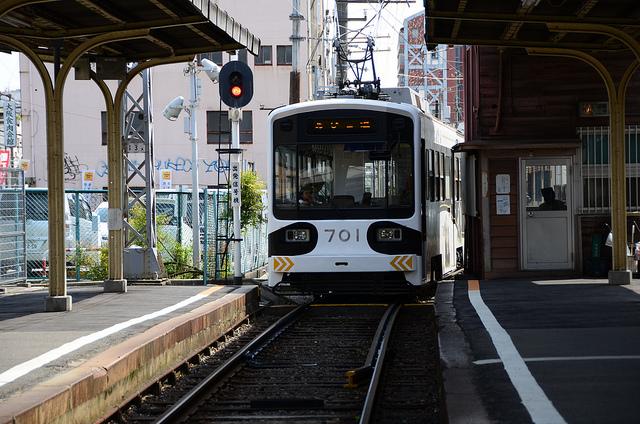Is the train looking at someone?
Write a very short answer. No. What is the color of the train?
Quick response, please. White. Is this station in Europe?
Quick response, please. Yes. What color is the train?
Write a very short answer. White. Which number is closer?
Concise answer only. 701. What mode of transportation is this?
Short answer required. Train. What number is on the front of the train?
Concise answer only. 701. Is this a passenger train?
Give a very brief answer. Yes. 